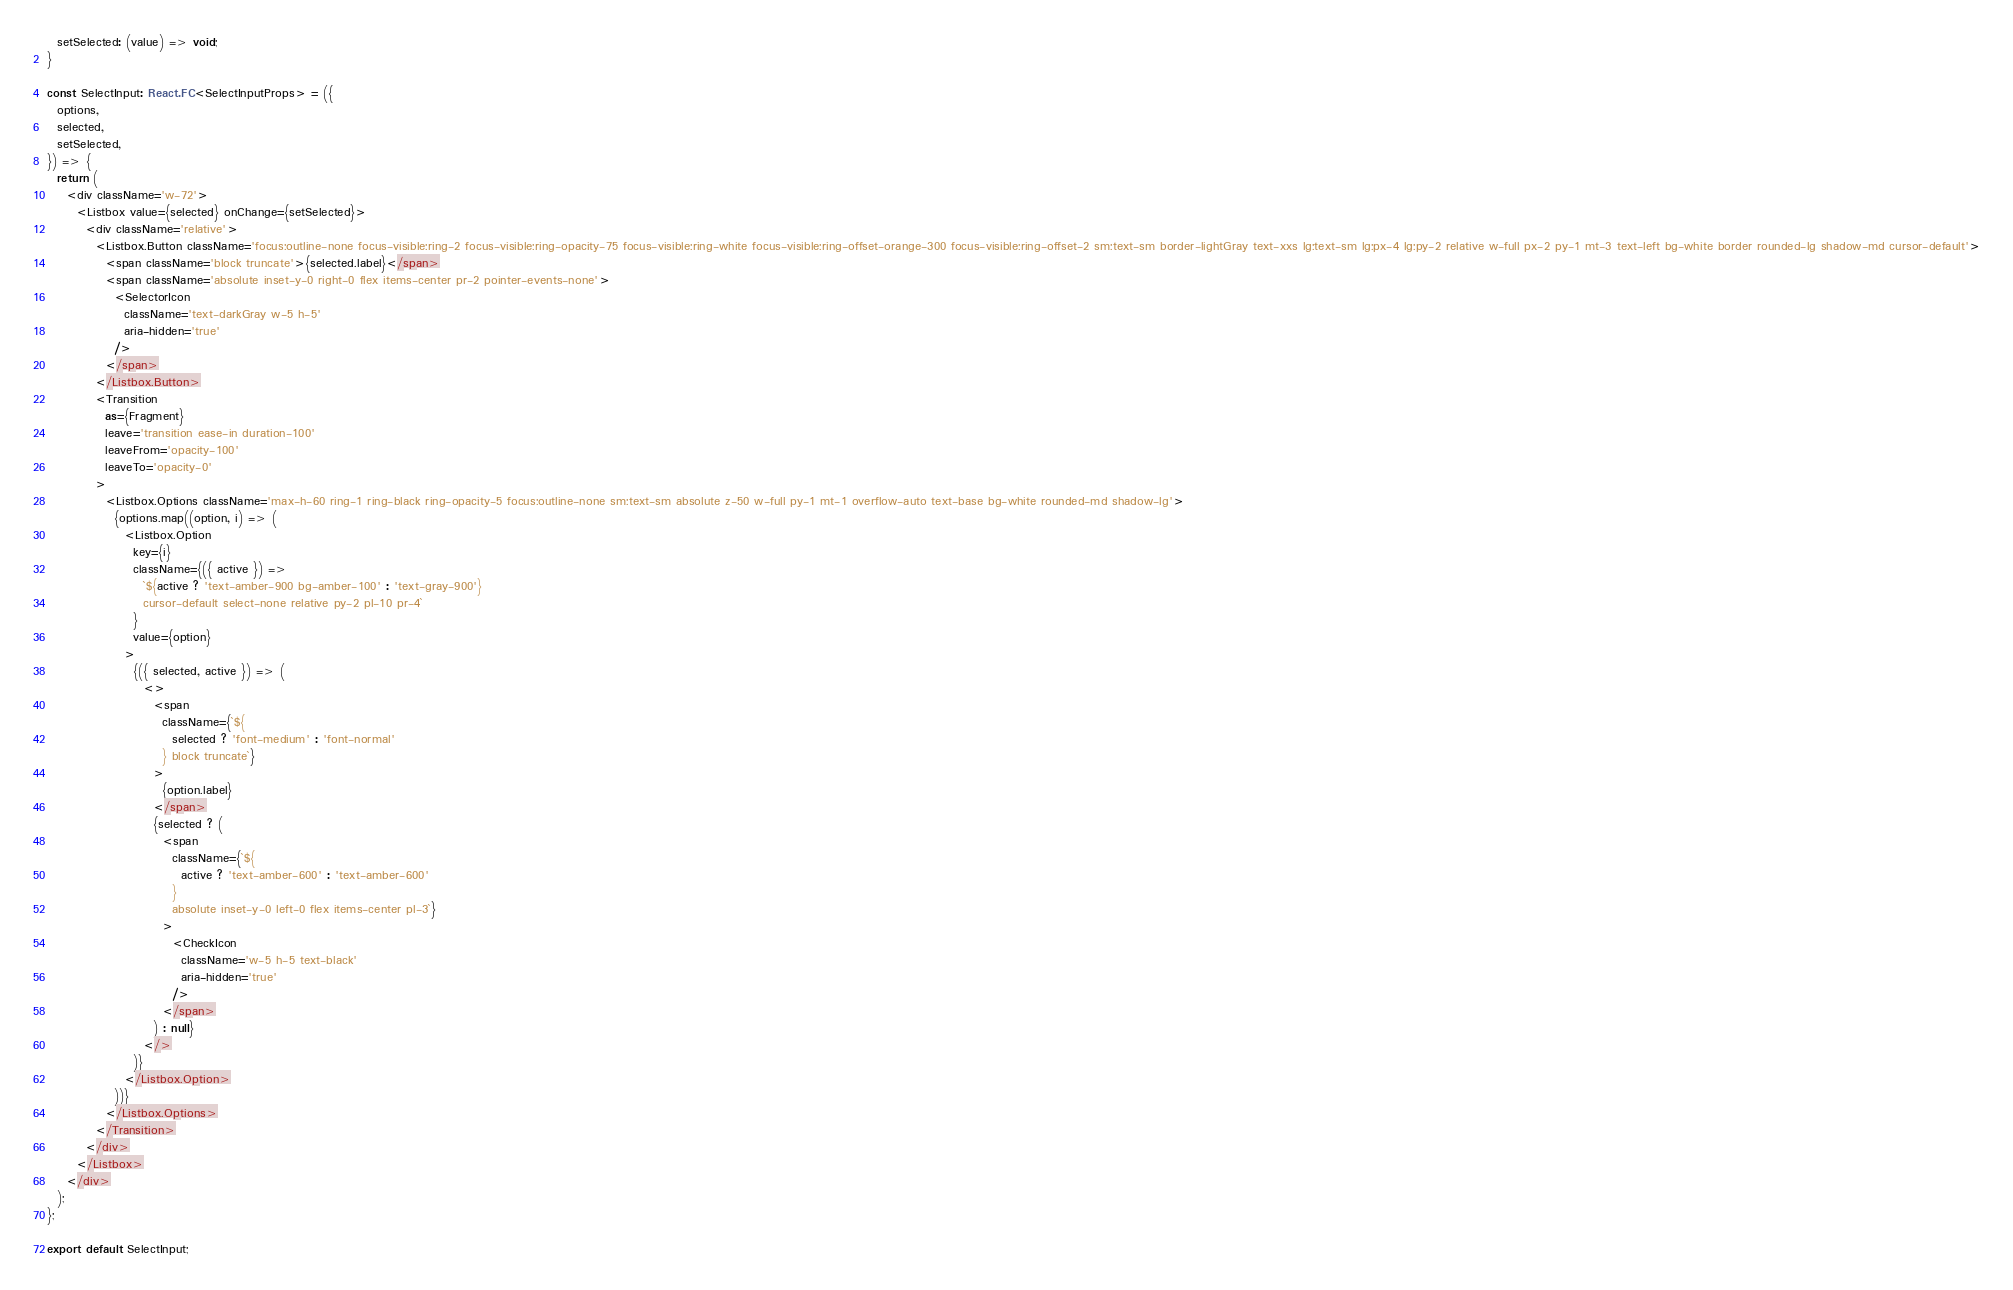Convert code to text. <code><loc_0><loc_0><loc_500><loc_500><_TypeScript_>  setSelected: (value) => void;
}

const SelectInput: React.FC<SelectInputProps> = ({
  options,
  selected,
  setSelected,
}) => {
  return (
    <div className='w-72'>
      <Listbox value={selected} onChange={setSelected}>
        <div className='relative'>
          <Listbox.Button className='focus:outline-none focus-visible:ring-2 focus-visible:ring-opacity-75 focus-visible:ring-white focus-visible:ring-offset-orange-300 focus-visible:ring-offset-2 sm:text-sm border-lightGray text-xxs lg:text-sm lg:px-4 lg:py-2 relative w-full px-2 py-1 mt-3 text-left bg-white border rounded-lg shadow-md cursor-default'>
            <span className='block truncate'>{selected.label}</span>
            <span className='absolute inset-y-0 right-0 flex items-center pr-2 pointer-events-none'>
              <SelectorIcon
                className='text-darkGray w-5 h-5'
                aria-hidden='true'
              />
            </span>
          </Listbox.Button>
          <Transition
            as={Fragment}
            leave='transition ease-in duration-100'
            leaveFrom='opacity-100'
            leaveTo='opacity-0'
          >
            <Listbox.Options className='max-h-60 ring-1 ring-black ring-opacity-5 focus:outline-none sm:text-sm absolute z-50 w-full py-1 mt-1 overflow-auto text-base bg-white rounded-md shadow-lg'>
              {options.map((option, i) => (
                <Listbox.Option
                  key={i}
                  className={({ active }) =>
                    `${active ? 'text-amber-900 bg-amber-100' : 'text-gray-900'}
                    cursor-default select-none relative py-2 pl-10 pr-4`
                  }
                  value={option}
                >
                  {({ selected, active }) => (
                    <>
                      <span
                        className={`${
                          selected ? 'font-medium' : 'font-normal'
                        } block truncate`}
                      >
                        {option.label}
                      </span>
                      {selected ? (
                        <span
                          className={`${
                            active ? 'text-amber-600' : 'text-amber-600'
                          }
                          absolute inset-y-0 left-0 flex items-center pl-3`}
                        >
                          <CheckIcon
                            className='w-5 h-5 text-black'
                            aria-hidden='true'
                          />
                        </span>
                      ) : null}
                    </>
                  )}
                </Listbox.Option>
              ))}
            </Listbox.Options>
          </Transition>
        </div>
      </Listbox>
    </div>
  );
};

export default SelectInput;
</code> 